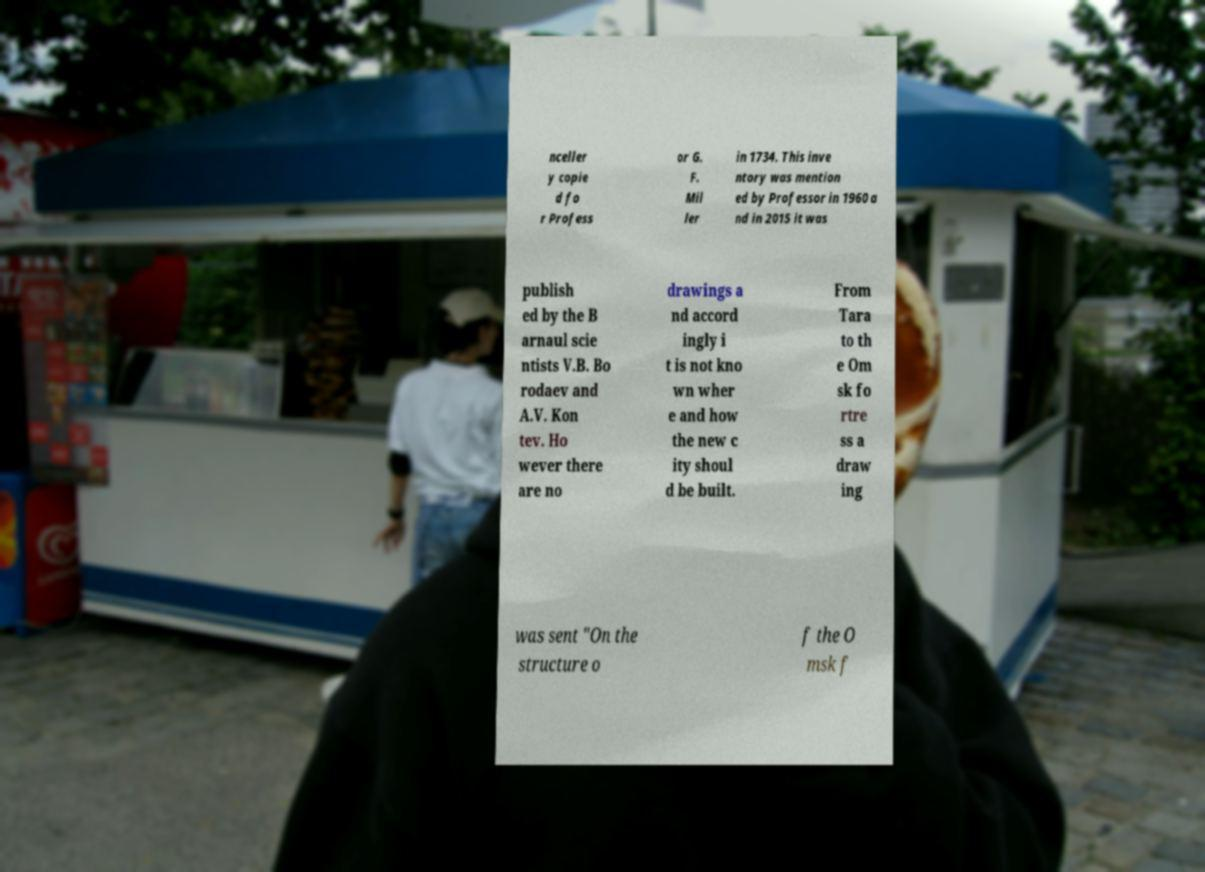Could you extract and type out the text from this image? nceller y copie d fo r Profess or G. F. Mil ler in 1734. This inve ntory was mention ed by Professor in 1960 a nd in 2015 it was publish ed by the B arnaul scie ntists V.B. Bo rodaev and A.V. Kon tev. Ho wever there are no drawings a nd accord ingly i t is not kno wn wher e and how the new c ity shoul d be built. From Tara to th e Om sk fo rtre ss a draw ing was sent "On the structure o f the O msk f 